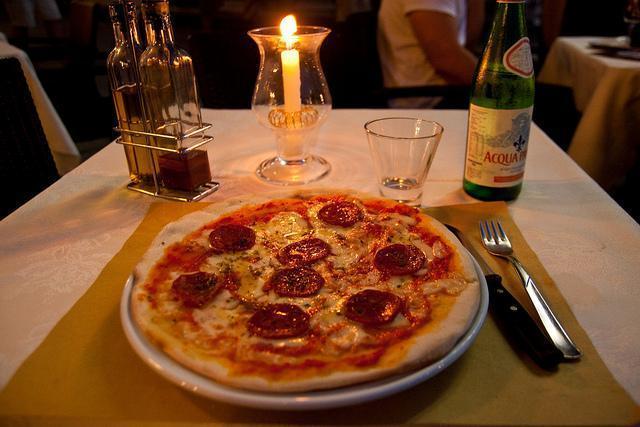How many bottles are there?
Give a very brief answer. 3. How many horses are there?
Give a very brief answer. 0. 